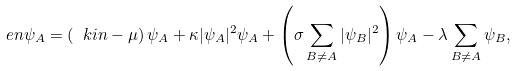<formula> <loc_0><loc_0><loc_500><loc_500>\ e n \psi _ { A } = \left ( \ k i n - \mu \right ) \psi _ { A } + \kappa | \psi _ { A } | ^ { 2 } \psi _ { A } + \left ( \sigma \sum _ { B \neq A } | \psi _ { B } | ^ { 2 } \right ) \psi _ { A } - \lambda \sum _ { B \neq A } \psi _ { B } ,</formula> 